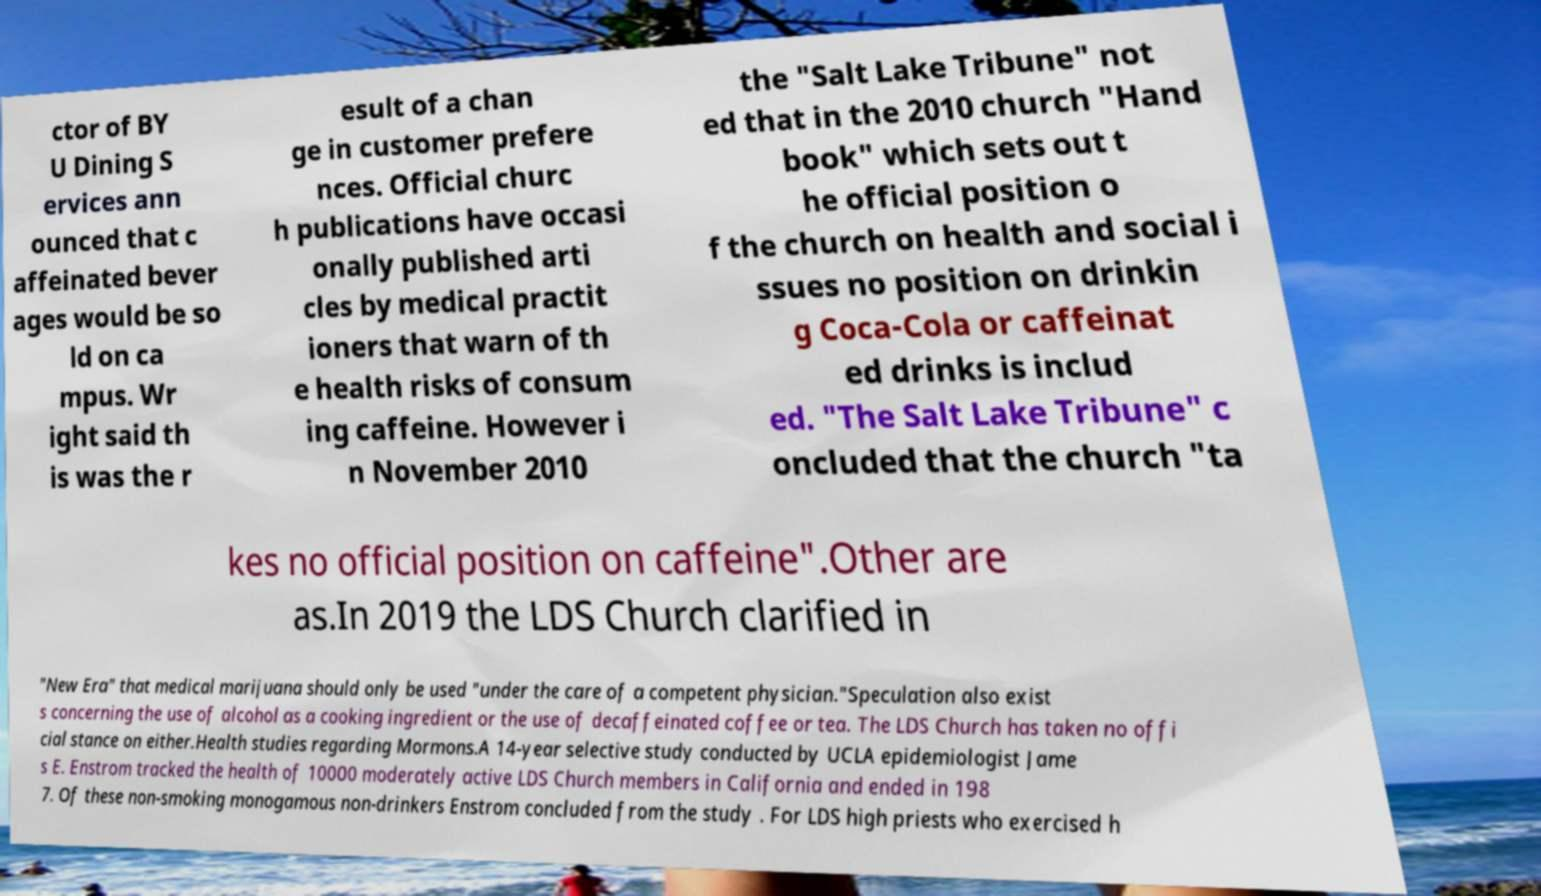Can you accurately transcribe the text from the provided image for me? ctor of BY U Dining S ervices ann ounced that c affeinated bever ages would be so ld on ca mpus. Wr ight said th is was the r esult of a chan ge in customer prefere nces. Official churc h publications have occasi onally published arti cles by medical practit ioners that warn of th e health risks of consum ing caffeine. However i n November 2010 the "Salt Lake Tribune" not ed that in the 2010 church "Hand book" which sets out t he official position o f the church on health and social i ssues no position on drinkin g Coca-Cola or caffeinat ed drinks is includ ed. "The Salt Lake Tribune" c oncluded that the church "ta kes no official position on caffeine".Other are as.In 2019 the LDS Church clarified in "New Era" that medical marijuana should only be used "under the care of a competent physician."Speculation also exist s concerning the use of alcohol as a cooking ingredient or the use of decaffeinated coffee or tea. The LDS Church has taken no offi cial stance on either.Health studies regarding Mormons.A 14-year selective study conducted by UCLA epidemiologist Jame s E. Enstrom tracked the health of 10000 moderately active LDS Church members in California and ended in 198 7. Of these non-smoking monogamous non-drinkers Enstrom concluded from the study . For LDS high priests who exercised h 